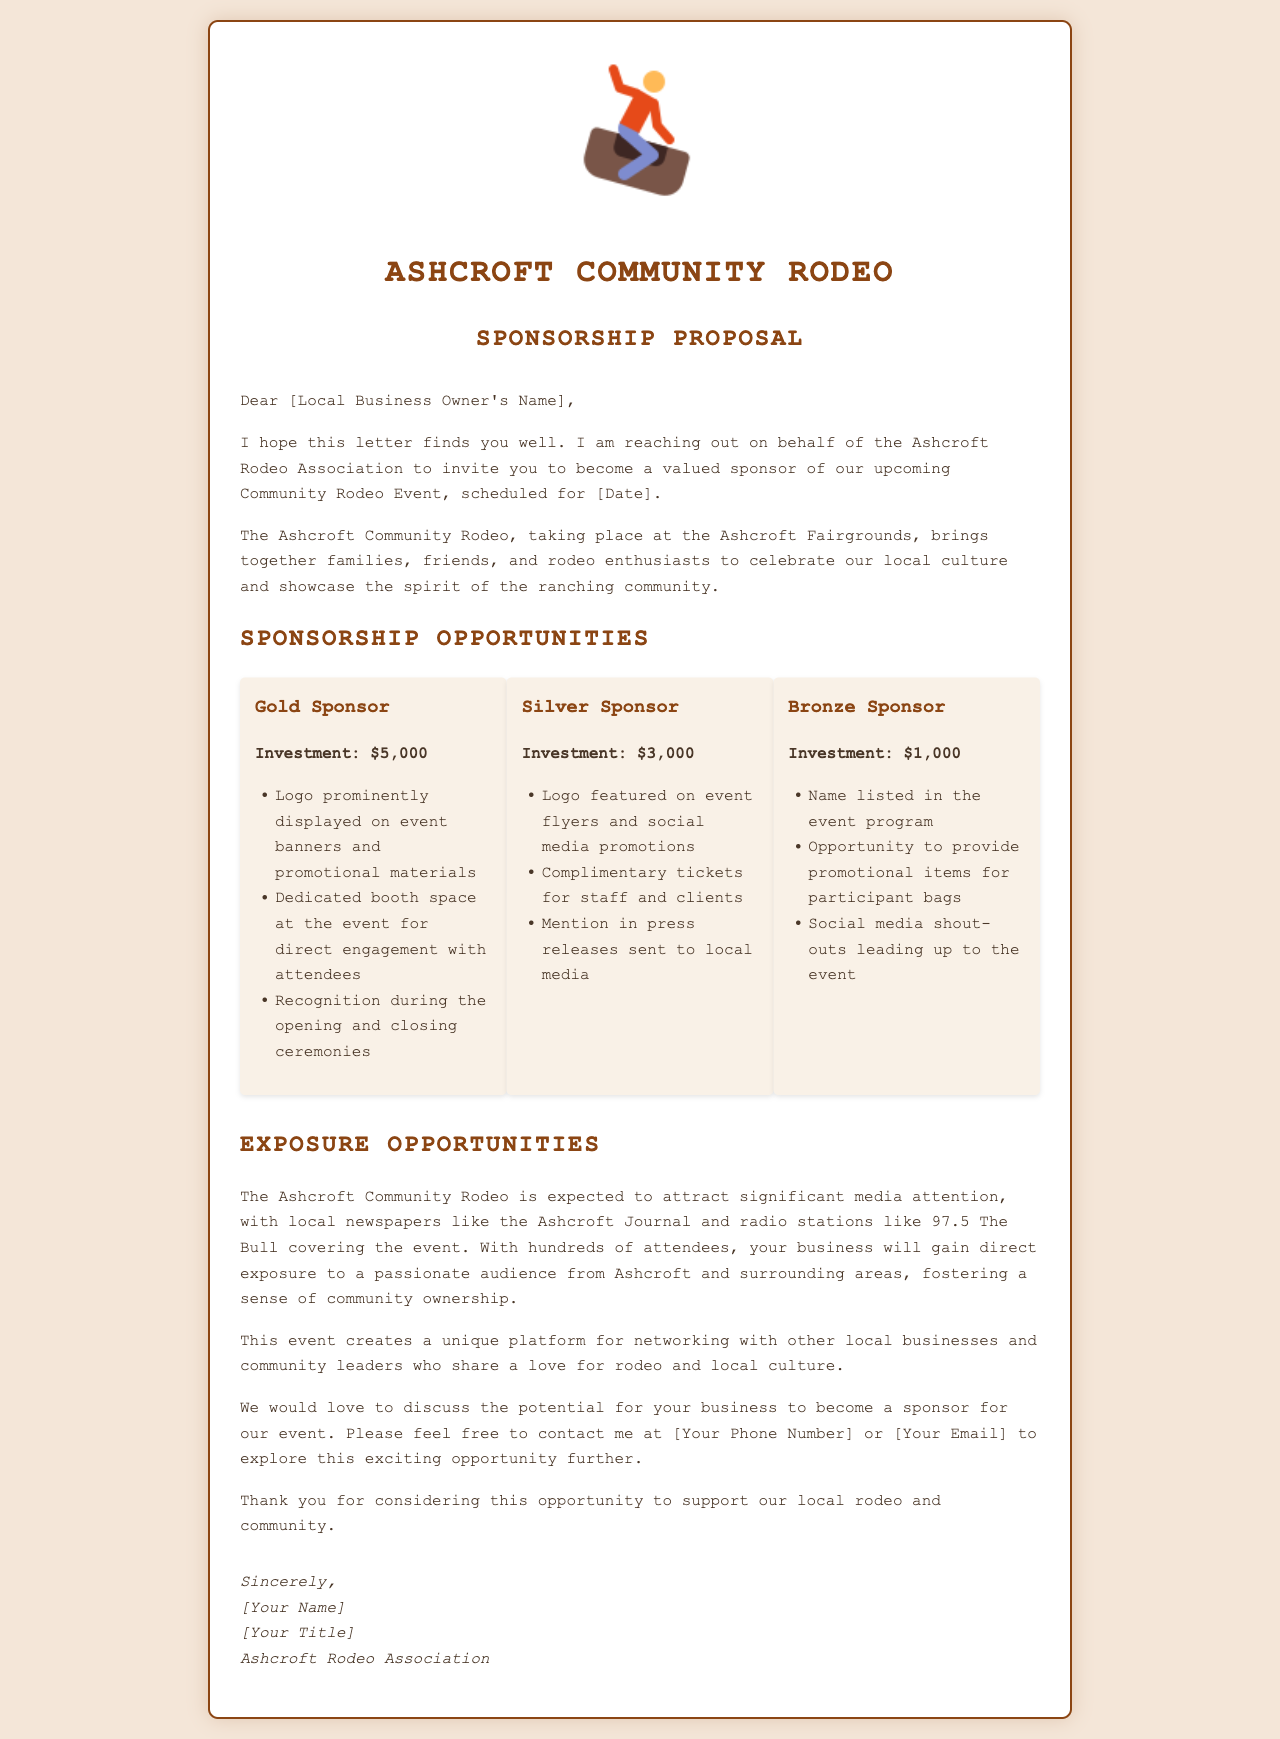what is the event date? The event date is indicated as [Date] in the document, which should be filled in with the specific date later.
Answer: [Date] who is the letter addressed to? The letter is addressed to a local business owner, noted as [Local Business Owner's Name].
Answer: [Local Business Owner's Name] what is the investment amount for a Gold Sponsor? The Gold Sponsor investment amount is specified in the document.
Answer: $5,000 which media outlets are expected to cover the event? The document lists local newspapers and radio stations that will cover the event, specifically mentioning them.
Answer: Ashcroft Journal, 97.5 The Bull what is a benefit of being a Bronze Sponsor? The document mentions a specific benefit related to the Bronze Sponsor level.
Answer: Name listed in the event program what unique opportunity does the event provide? The document describes a unique opportunity that the rodeo event creates for local businesses and community leaders.
Answer: Networking who is representing the Ashcroft Rodeo Association? The signature section at the end of the document includes this information.
Answer: [Your Name] what type of letter is this document? The document is categorized by its content and purpose.
Answer: Sponsorship proposal letter 